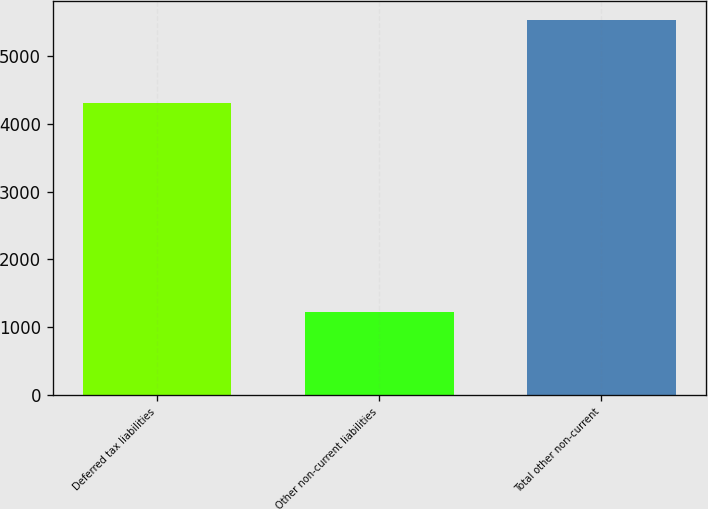<chart> <loc_0><loc_0><loc_500><loc_500><bar_chart><fcel>Deferred tax liabilities<fcel>Other non-current liabilities<fcel>Total other non-current<nl><fcel>4300<fcel>1231<fcel>5531<nl></chart> 